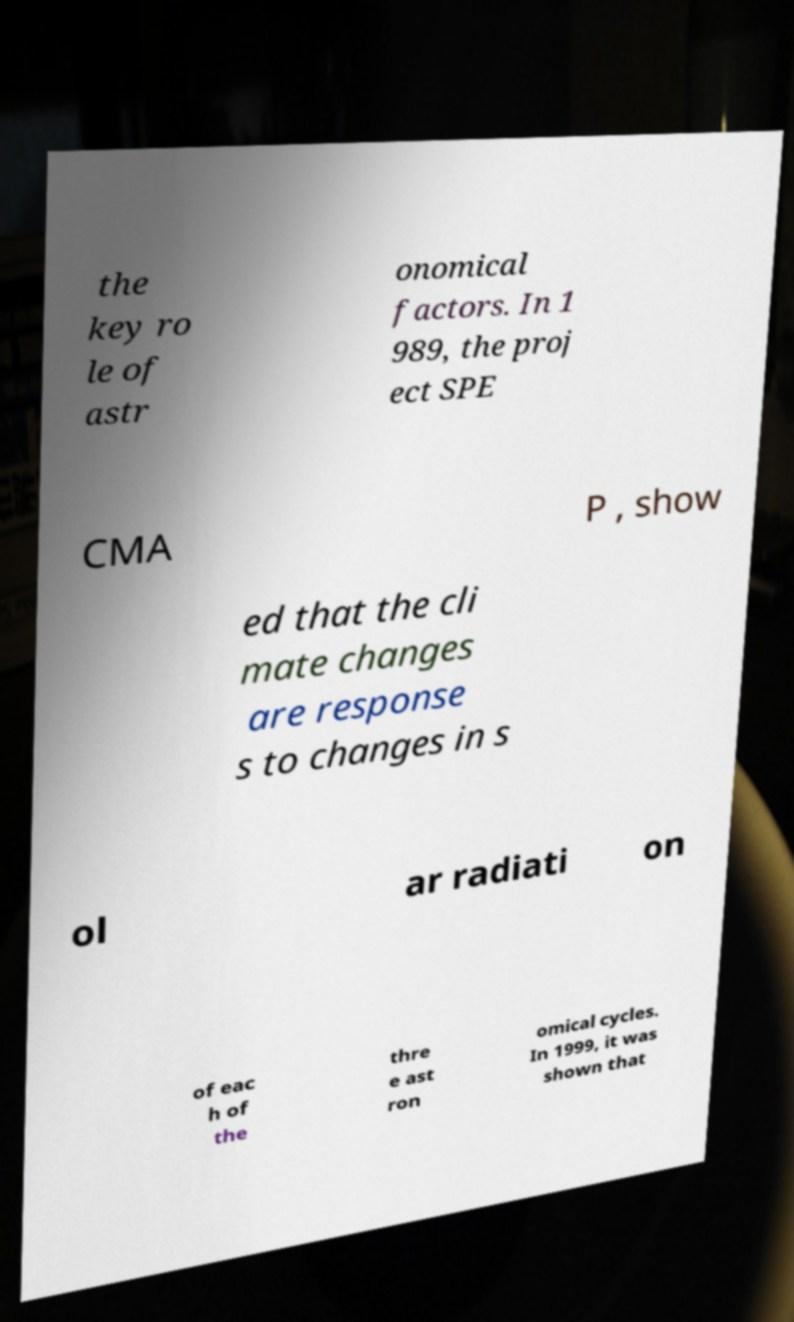Could you assist in decoding the text presented in this image and type it out clearly? the key ro le of astr onomical factors. In 1 989, the proj ect SPE CMA P , show ed that the cli mate changes are response s to changes in s ol ar radiati on of eac h of the thre e ast ron omical cycles. In 1999, it was shown that 